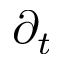<formula> <loc_0><loc_0><loc_500><loc_500>\partial _ { t }</formula> 